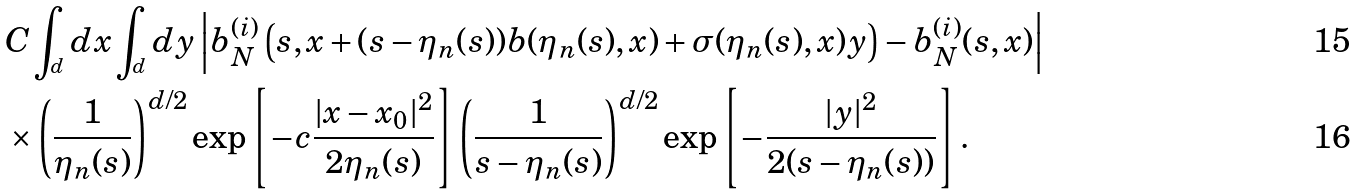Convert formula to latex. <formula><loc_0><loc_0><loc_500><loc_500>& C \int _ { \real ^ { d } } d x \int _ { \real ^ { d } } d y \left | b _ { N } ^ { ( i ) } \left ( s , x + ( s - \eta _ { n } ( s ) ) b ( \eta _ { n } ( s ) , x ) + \sigma ( \eta _ { n } ( s ) , x ) y \right ) - b _ { N } ^ { ( i ) } ( s , x ) \right | \\ & \times \left ( \frac { 1 } { \eta _ { n } ( s ) } \right ) ^ { d / 2 } \exp \left [ - c \frac { | x - x _ { 0 } | ^ { 2 } } { 2 \eta _ { n } ( s ) } \right ] \left ( \frac { 1 } { s - \eta _ { n } ( s ) } \right ) ^ { d / 2 } \exp \left [ - \frac { | y | ^ { 2 } } { 2 ( s - \eta _ { n } ( s ) ) } \right ] .</formula> 